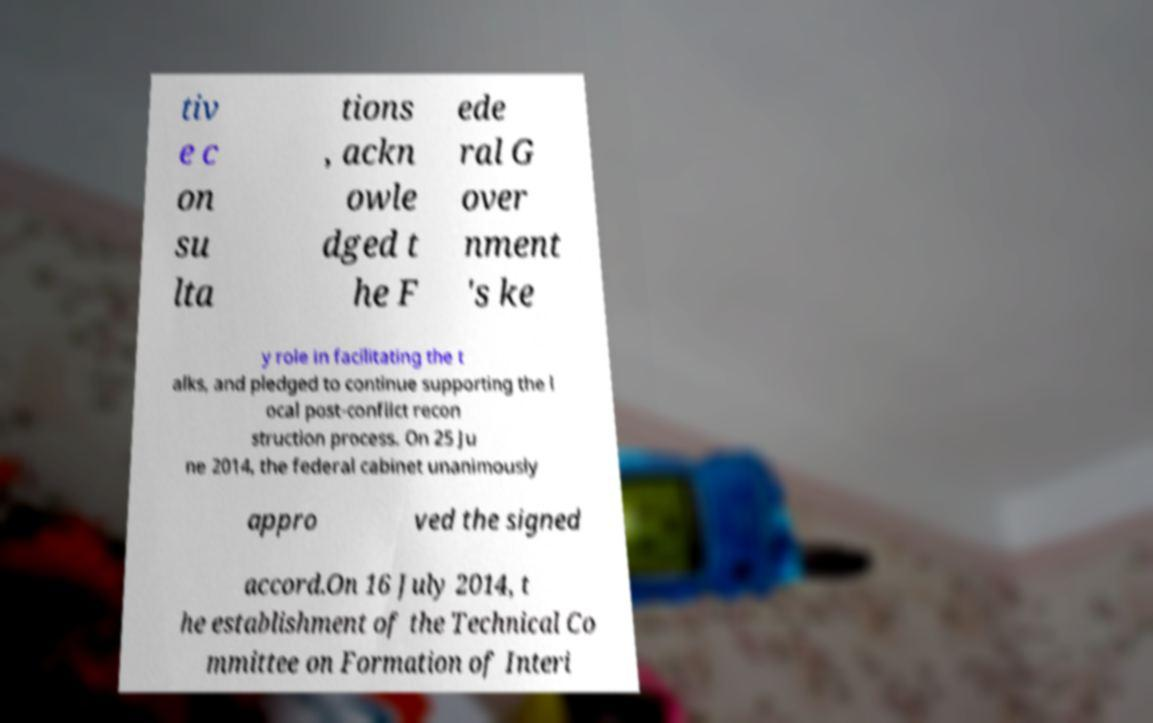I need the written content from this picture converted into text. Can you do that? tiv e c on su lta tions , ackn owle dged t he F ede ral G over nment 's ke y role in facilitating the t alks, and pledged to continue supporting the l ocal post-conflict recon struction process. On 25 Ju ne 2014, the federal cabinet unanimously appro ved the signed accord.On 16 July 2014, t he establishment of the Technical Co mmittee on Formation of Interi 